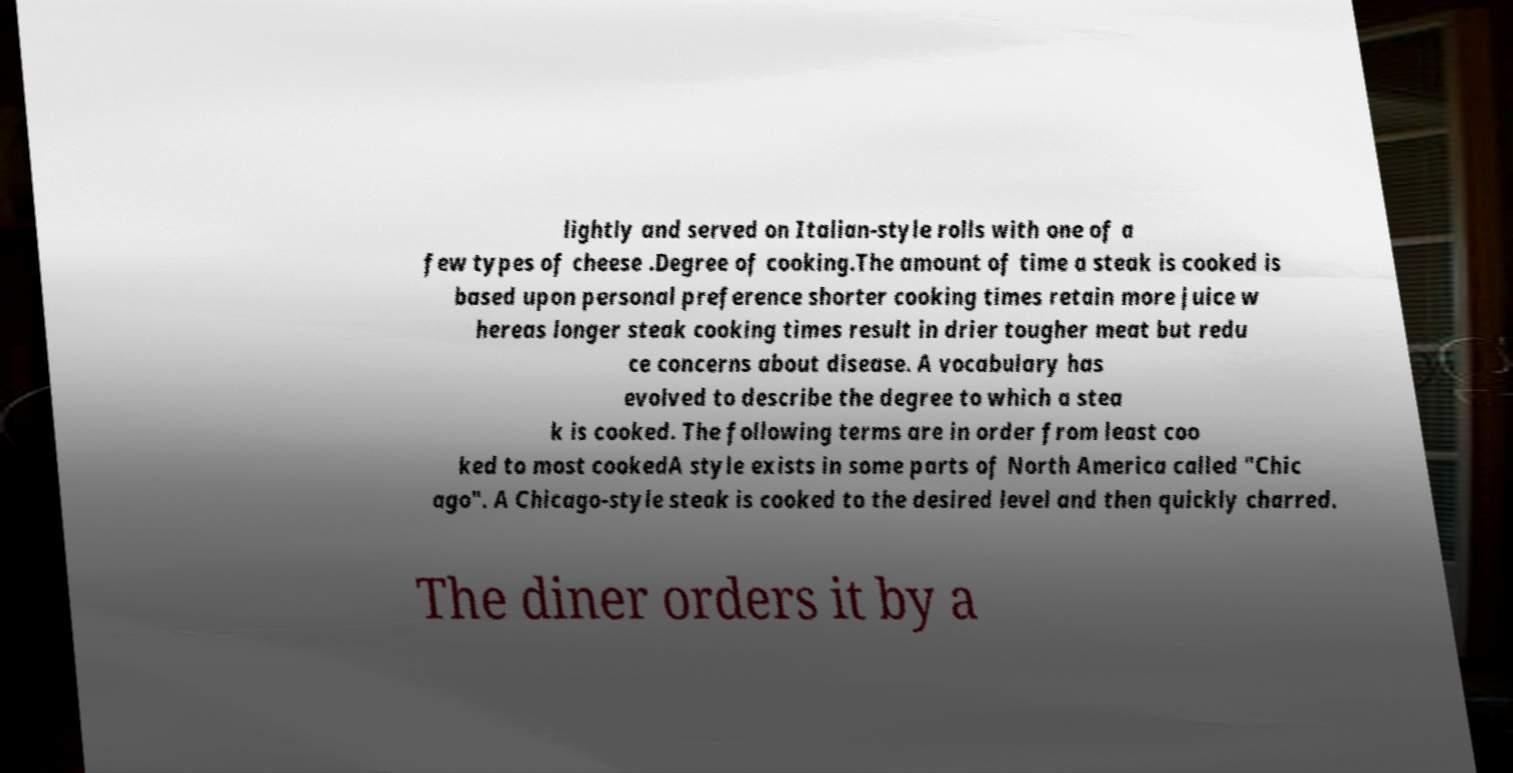Please identify and transcribe the text found in this image. lightly and served on Italian-style rolls with one of a few types of cheese .Degree of cooking.The amount of time a steak is cooked is based upon personal preference shorter cooking times retain more juice w hereas longer steak cooking times result in drier tougher meat but redu ce concerns about disease. A vocabulary has evolved to describe the degree to which a stea k is cooked. The following terms are in order from least coo ked to most cookedA style exists in some parts of North America called "Chic ago". A Chicago-style steak is cooked to the desired level and then quickly charred. The diner orders it by a 